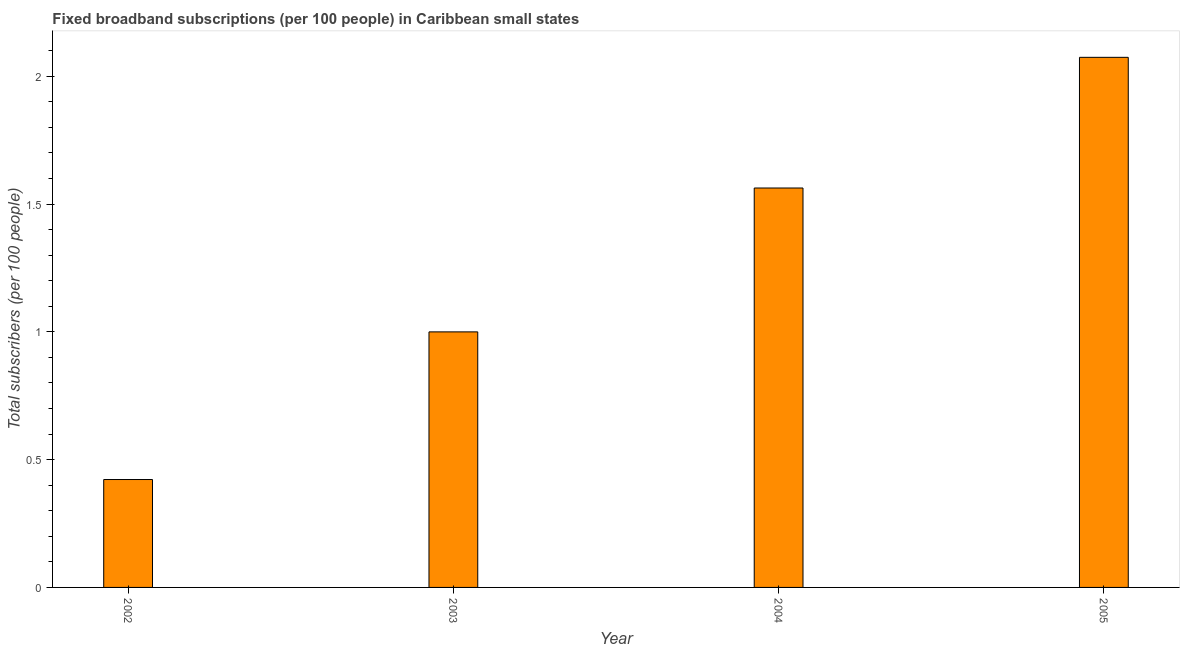What is the title of the graph?
Ensure brevity in your answer.  Fixed broadband subscriptions (per 100 people) in Caribbean small states. What is the label or title of the X-axis?
Your answer should be very brief. Year. What is the label or title of the Y-axis?
Keep it short and to the point. Total subscribers (per 100 people). What is the total number of fixed broadband subscriptions in 2002?
Keep it short and to the point. 0.42. Across all years, what is the maximum total number of fixed broadband subscriptions?
Offer a very short reply. 2.07. Across all years, what is the minimum total number of fixed broadband subscriptions?
Provide a short and direct response. 0.42. In which year was the total number of fixed broadband subscriptions maximum?
Keep it short and to the point. 2005. In which year was the total number of fixed broadband subscriptions minimum?
Keep it short and to the point. 2002. What is the sum of the total number of fixed broadband subscriptions?
Give a very brief answer. 5.06. What is the difference between the total number of fixed broadband subscriptions in 2003 and 2004?
Offer a very short reply. -0.56. What is the average total number of fixed broadband subscriptions per year?
Your response must be concise. 1.26. What is the median total number of fixed broadband subscriptions?
Provide a succinct answer. 1.28. In how many years, is the total number of fixed broadband subscriptions greater than 1 ?
Ensure brevity in your answer.  2. Do a majority of the years between 2003 and 2004 (inclusive) have total number of fixed broadband subscriptions greater than 2 ?
Provide a succinct answer. No. What is the ratio of the total number of fixed broadband subscriptions in 2002 to that in 2004?
Provide a succinct answer. 0.27. What is the difference between the highest and the second highest total number of fixed broadband subscriptions?
Provide a succinct answer. 0.51. What is the difference between the highest and the lowest total number of fixed broadband subscriptions?
Keep it short and to the point. 1.65. What is the Total subscribers (per 100 people) in 2002?
Provide a short and direct response. 0.42. What is the Total subscribers (per 100 people) of 2003?
Keep it short and to the point. 1. What is the Total subscribers (per 100 people) of 2004?
Offer a terse response. 1.56. What is the Total subscribers (per 100 people) in 2005?
Your answer should be very brief. 2.07. What is the difference between the Total subscribers (per 100 people) in 2002 and 2003?
Provide a succinct answer. -0.58. What is the difference between the Total subscribers (per 100 people) in 2002 and 2004?
Keep it short and to the point. -1.14. What is the difference between the Total subscribers (per 100 people) in 2002 and 2005?
Your answer should be compact. -1.65. What is the difference between the Total subscribers (per 100 people) in 2003 and 2004?
Your answer should be very brief. -0.56. What is the difference between the Total subscribers (per 100 people) in 2003 and 2005?
Your response must be concise. -1.07. What is the difference between the Total subscribers (per 100 people) in 2004 and 2005?
Keep it short and to the point. -0.51. What is the ratio of the Total subscribers (per 100 people) in 2002 to that in 2003?
Your answer should be compact. 0.42. What is the ratio of the Total subscribers (per 100 people) in 2002 to that in 2004?
Ensure brevity in your answer.  0.27. What is the ratio of the Total subscribers (per 100 people) in 2002 to that in 2005?
Make the answer very short. 0.2. What is the ratio of the Total subscribers (per 100 people) in 2003 to that in 2004?
Offer a terse response. 0.64. What is the ratio of the Total subscribers (per 100 people) in 2003 to that in 2005?
Your response must be concise. 0.48. What is the ratio of the Total subscribers (per 100 people) in 2004 to that in 2005?
Ensure brevity in your answer.  0.75. 